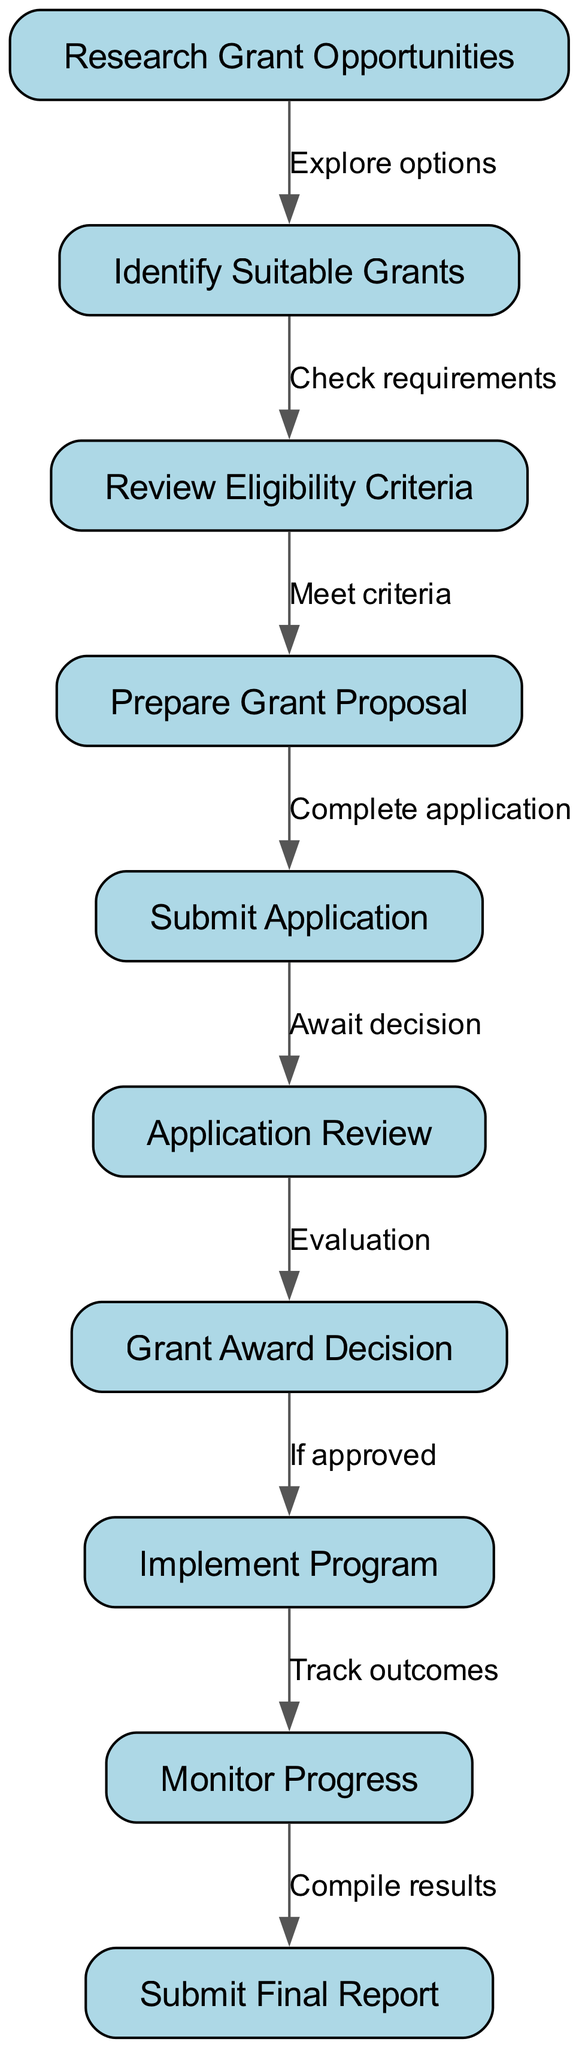What is the first step in the grant application process? The first step in the flowchart is labeled "Research Grant Opportunities." This is indicated as the starting node from which all other processes flow.
Answer: Research Grant Opportunities How many nodes are in the diagram? By counting the total number of distinct nodes represented in the diagram, which are listed as "Research Grant Opportunities," "Identify Suitable Grants," "Review Eligibility Criteria," "Prepare Grant Proposal," "Submit Application," "Application Review," "Grant Award Decision," "Implement Program," "Monitor Progress," and "Submit Final Report," we find there are ten nodes.
Answer: 10 Which step follows "Submit Application"? Following the node labeled "Submit Application," the next step in the flowchart is represented by the node "Application Review." This is directly connected by an edge showing the sequential flow.
Answer: Application Review What happens if the grant is approved? If the grant is approved, according to the flowchart, the next step is to "Implement Program," which directly follows the "Grant Award Decision" node when a positive outcome is reached.
Answer: Implement Program How do you move from "Identify Suitable Grants" to "Prepare Grant Proposal"? To move from "Identify Suitable Grants" to "Prepare Grant Proposal," one must first "Review Eligibility Criteria," which is depicted as a required step before moving forward to prepare the actual proposal. This indicates that eligibility must be assessed first.
Answer: Review Eligibility Criteria What is the last step in the process? The final step in the grant application process, as shown in the diagram, is "Submit Final Report." This node represents the concluding action that has to be taken after the program implementation and progress monitoring.
Answer: Submit Final Report Which edges connect "Implement Program" and "Submit Final Report"? The edge connecting "Implement Program" to "Submit Final Report" is the one labeled "Compile results." This signifies that after monitoring progress, the outcomes should be compiled which leads to submitting the final report.
Answer: Compile results What is required before submitting the application? Before submitting the application, it is necessary to "Prepare Grant Proposal," which is indicated in the flow after reviewing eligibility criteria and before the submission step. This indicates that preparation is essential before final application submission.
Answer: Prepare Grant Proposal What does "Monitor Progress" lead to? "Monitor Progress" leads to the step "Submit Final Report," which indicates that after the implementation of the program and tracking its outcomes, a final report must be compiled and submitted as the next step in the process.
Answer: Submit Final Report 